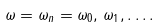<formula> <loc_0><loc_0><loc_500><loc_500>\omega = \omega _ { n } = \omega _ { 0 } , \, \omega _ { 1 } , \dots .</formula> 